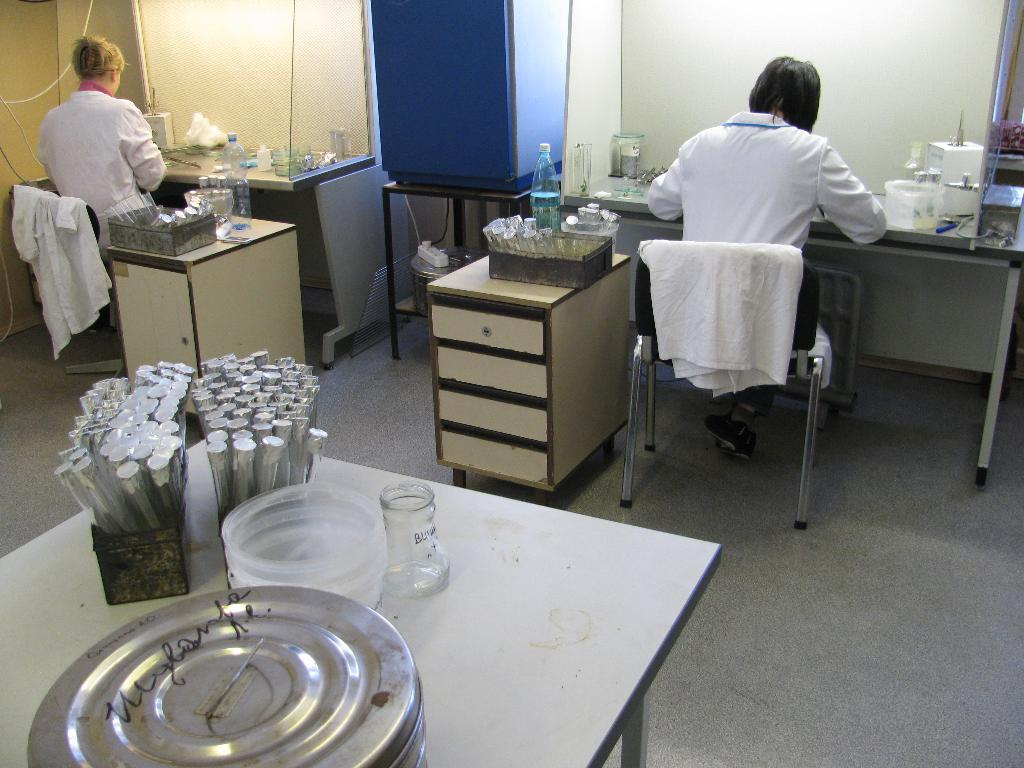What is located on the table in the image? There are objects on a table in the image. How many people are present in the image? There are two women in the image. What are the women doing in the image? The women are doing something on the table. What is the weather like in the image? The background of the image is sunny. What type of cable can be seen connecting the two women in the image? There is no cable connecting the two women in the image. What activity are the women participating in while connected by the cable? Since there is no cable connecting the women, they are not participating in any activity involving a cable. 